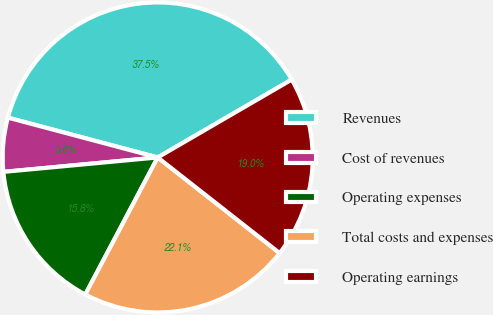Convert chart to OTSL. <chart><loc_0><loc_0><loc_500><loc_500><pie_chart><fcel>Revenues<fcel>Cost of revenues<fcel>Operating expenses<fcel>Total costs and expenses<fcel>Operating earnings<nl><fcel>37.49%<fcel>5.62%<fcel>15.78%<fcel>22.15%<fcel>18.96%<nl></chart> 